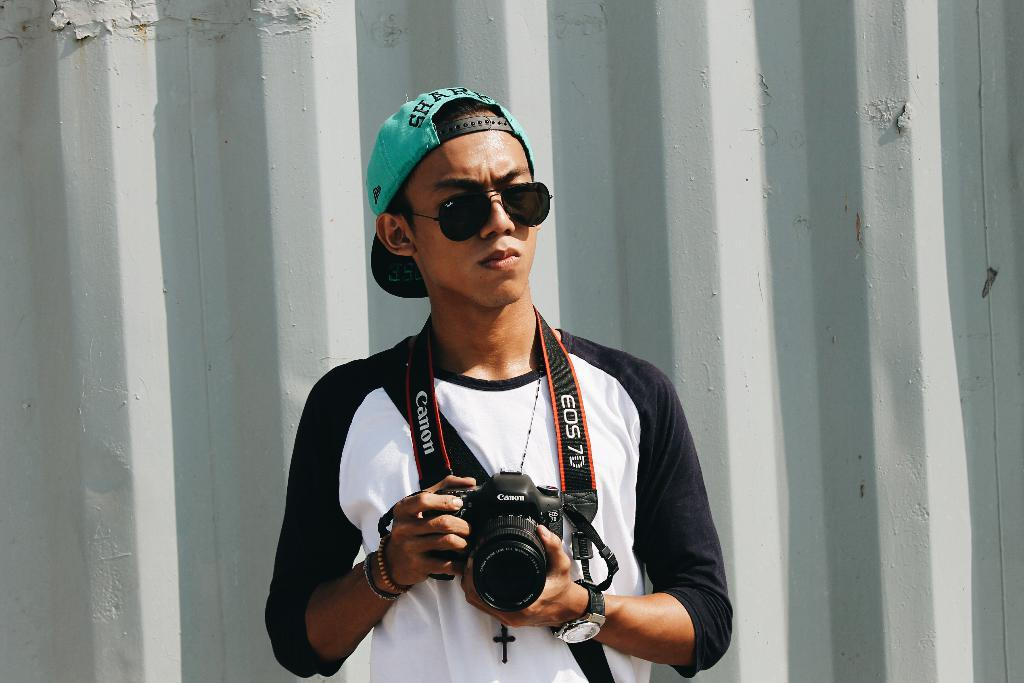What color is the t-shirt the man is wearing in the image? The man is wearing a black and white t-shirt. What type of protective eyewear is the man wearing? The man is wearing goggles. What type of headwear is the man wearing? The man is wearing a cap. What is the man holding in the image? The man is holding a camera. What type of flowers can be seen growing around the man in the image? There are no flowers visible in the image; the man is the main subject. 